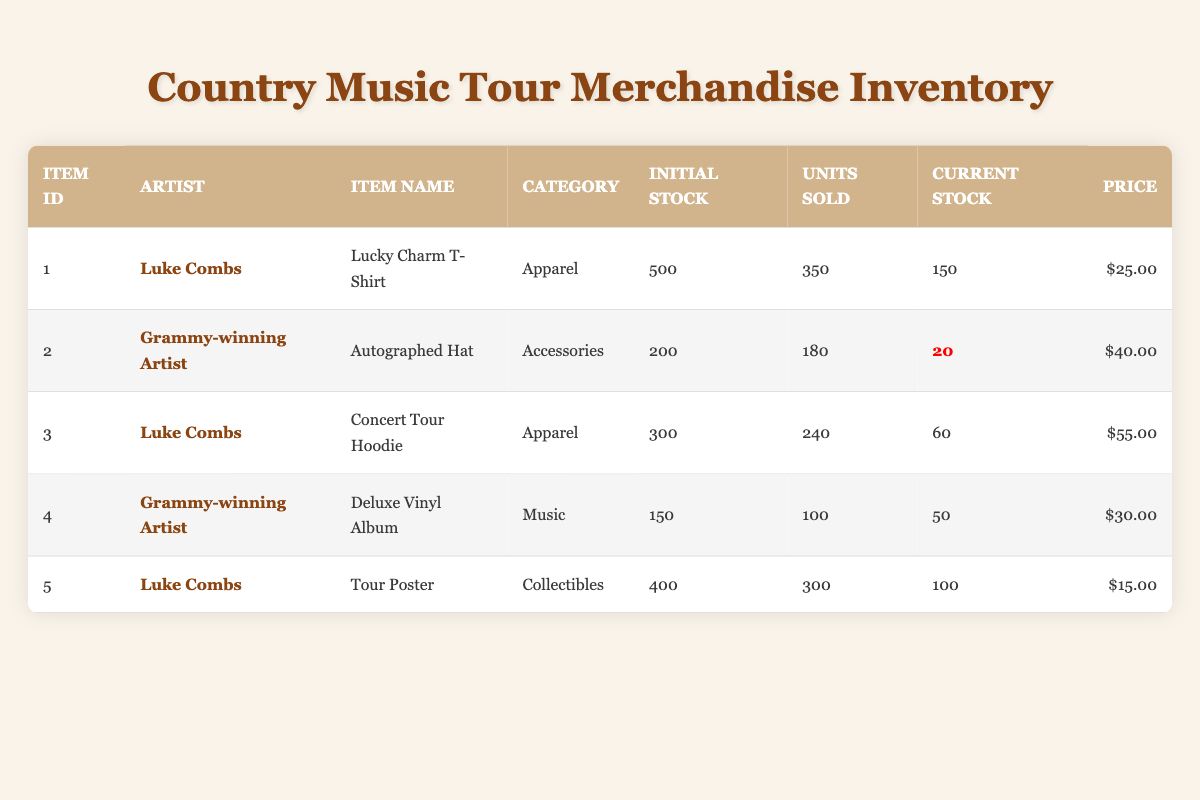What is the current stock of the Autographed Hat? The table shows the current stock of the Autographed Hat under the "Current Stock" column, which is 20 units.
Answer: 20 How many units of the Lucky Charm T-Shirt have been sold? The "Units Sold" column in the table for the Lucky Charm T-Shirt indicates that 350 units have been sold.
Answer: 350 Which item has the highest price per unit? To find the highest price, we compare the "Price" column values: $25.00 (Lucky Charm T-Shirt), $40.00 (Autographed Hat), $55.00 (Concert Tour Hoodie), $30.00 (Deluxe Vinyl Album), and $15.00 (Tour Poster). The highest price is $55.00 for the Concert Tour Hoodie.
Answer: $55.00 What is the total initial stock of merchandise for both artists? The initial stock for Luke Combs is 500 (T-Shirt) + 300 (Hoodie) + 400 (Poster) = 1200. For the Grammy-winning Artist, it is 200 (Hat) + 150 (Vinyl) = 350. Summing these gives 1200 + 350 = 1550.
Answer: 1550 Is the current stock of the Deluxe Vinyl Album low? The current stock for the Deluxe Vinyl Album is shown as 50. If we consider low stock to be less than 50, then it is not low as it is equal to 50.
Answer: No Which item had the largest number of units sold? We look at the "Units Sold" column: 350 (T-Shirt), 180 (Hat), 240 (Hoodie), 100 (Vinyl), 300 (Poster). The largest number is 350 for the Lucky Charm T-Shirt.
Answer: Lucky Charm T-Shirt How many more units of the Concert Tour Hoodie could potentially be sold before reaching zero stock? The current stock of the Concert Tour Hoodie is 60, which means 60 more units could potentially be sold before it reaches zero stock.
Answer: 60 What percentage of the initial stock of the Autographed Hat has been sold? To find the percentage, we take the units sold (180) divided by the initial stock (200), which gives 180/200 = 0.90, or 90%.
Answer: 90% How many total collectible items are there in stock currently? The only collectible listed is the Tour Poster with a current stock of 100.
Answer: 100 